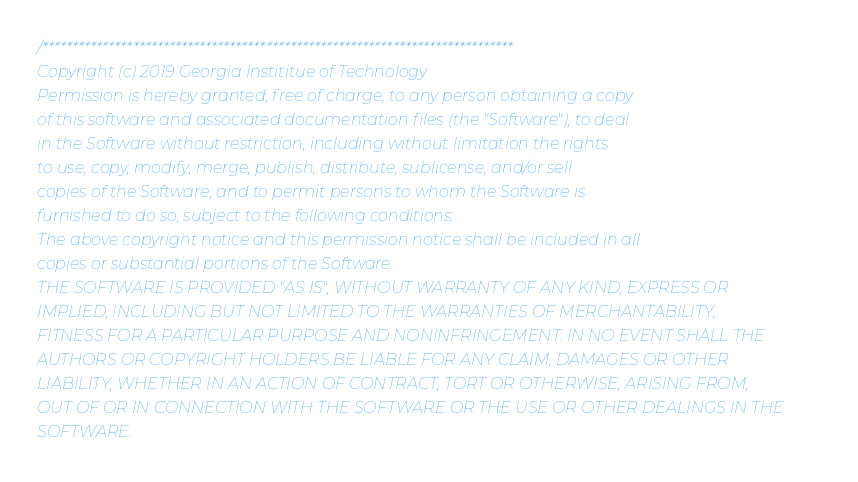<code> <loc_0><loc_0><loc_500><loc_500><_C++_>/******************************************************************************
Copyright (c) 2019 Georgia Instititue of Technology
Permission is hereby granted, free of charge, to any person obtaining a copy
of this software and associated documentation files (the "Software"), to deal
in the Software without restriction, including without limitation the rights
to use, copy, modify, merge, publish, distribute, sublicense, and/or sell
copies of the Software, and to permit persons to whom the Software is
furnished to do so, subject to the following conditions:
The above copyright notice and this permission notice shall be included in all
copies or substantial portions of the Software.
THE SOFTWARE IS PROVIDED "AS IS", WITHOUT WARRANTY OF ANY KIND, EXPRESS OR
IMPLIED, INCLUDING BUT NOT LIMITED TO THE WARRANTIES OF MERCHANTABILITY,
FITNESS FOR A PARTICULAR PURPOSE AND NONINFRINGEMENT. IN NO EVENT SHALL THE
AUTHORS OR COPYRIGHT HOLDERS BE LIABLE FOR ANY CLAIM, DAMAGES OR OTHER
LIABILITY, WHETHER IN AN ACTION OF CONTRACT, TORT OR OTHERWISE, ARISING FROM,
OUT OF OR IN CONNECTION WITH THE SOFTWARE OR THE USE OR OTHER DEALINGS IN THE
SOFTWARE.
</code> 